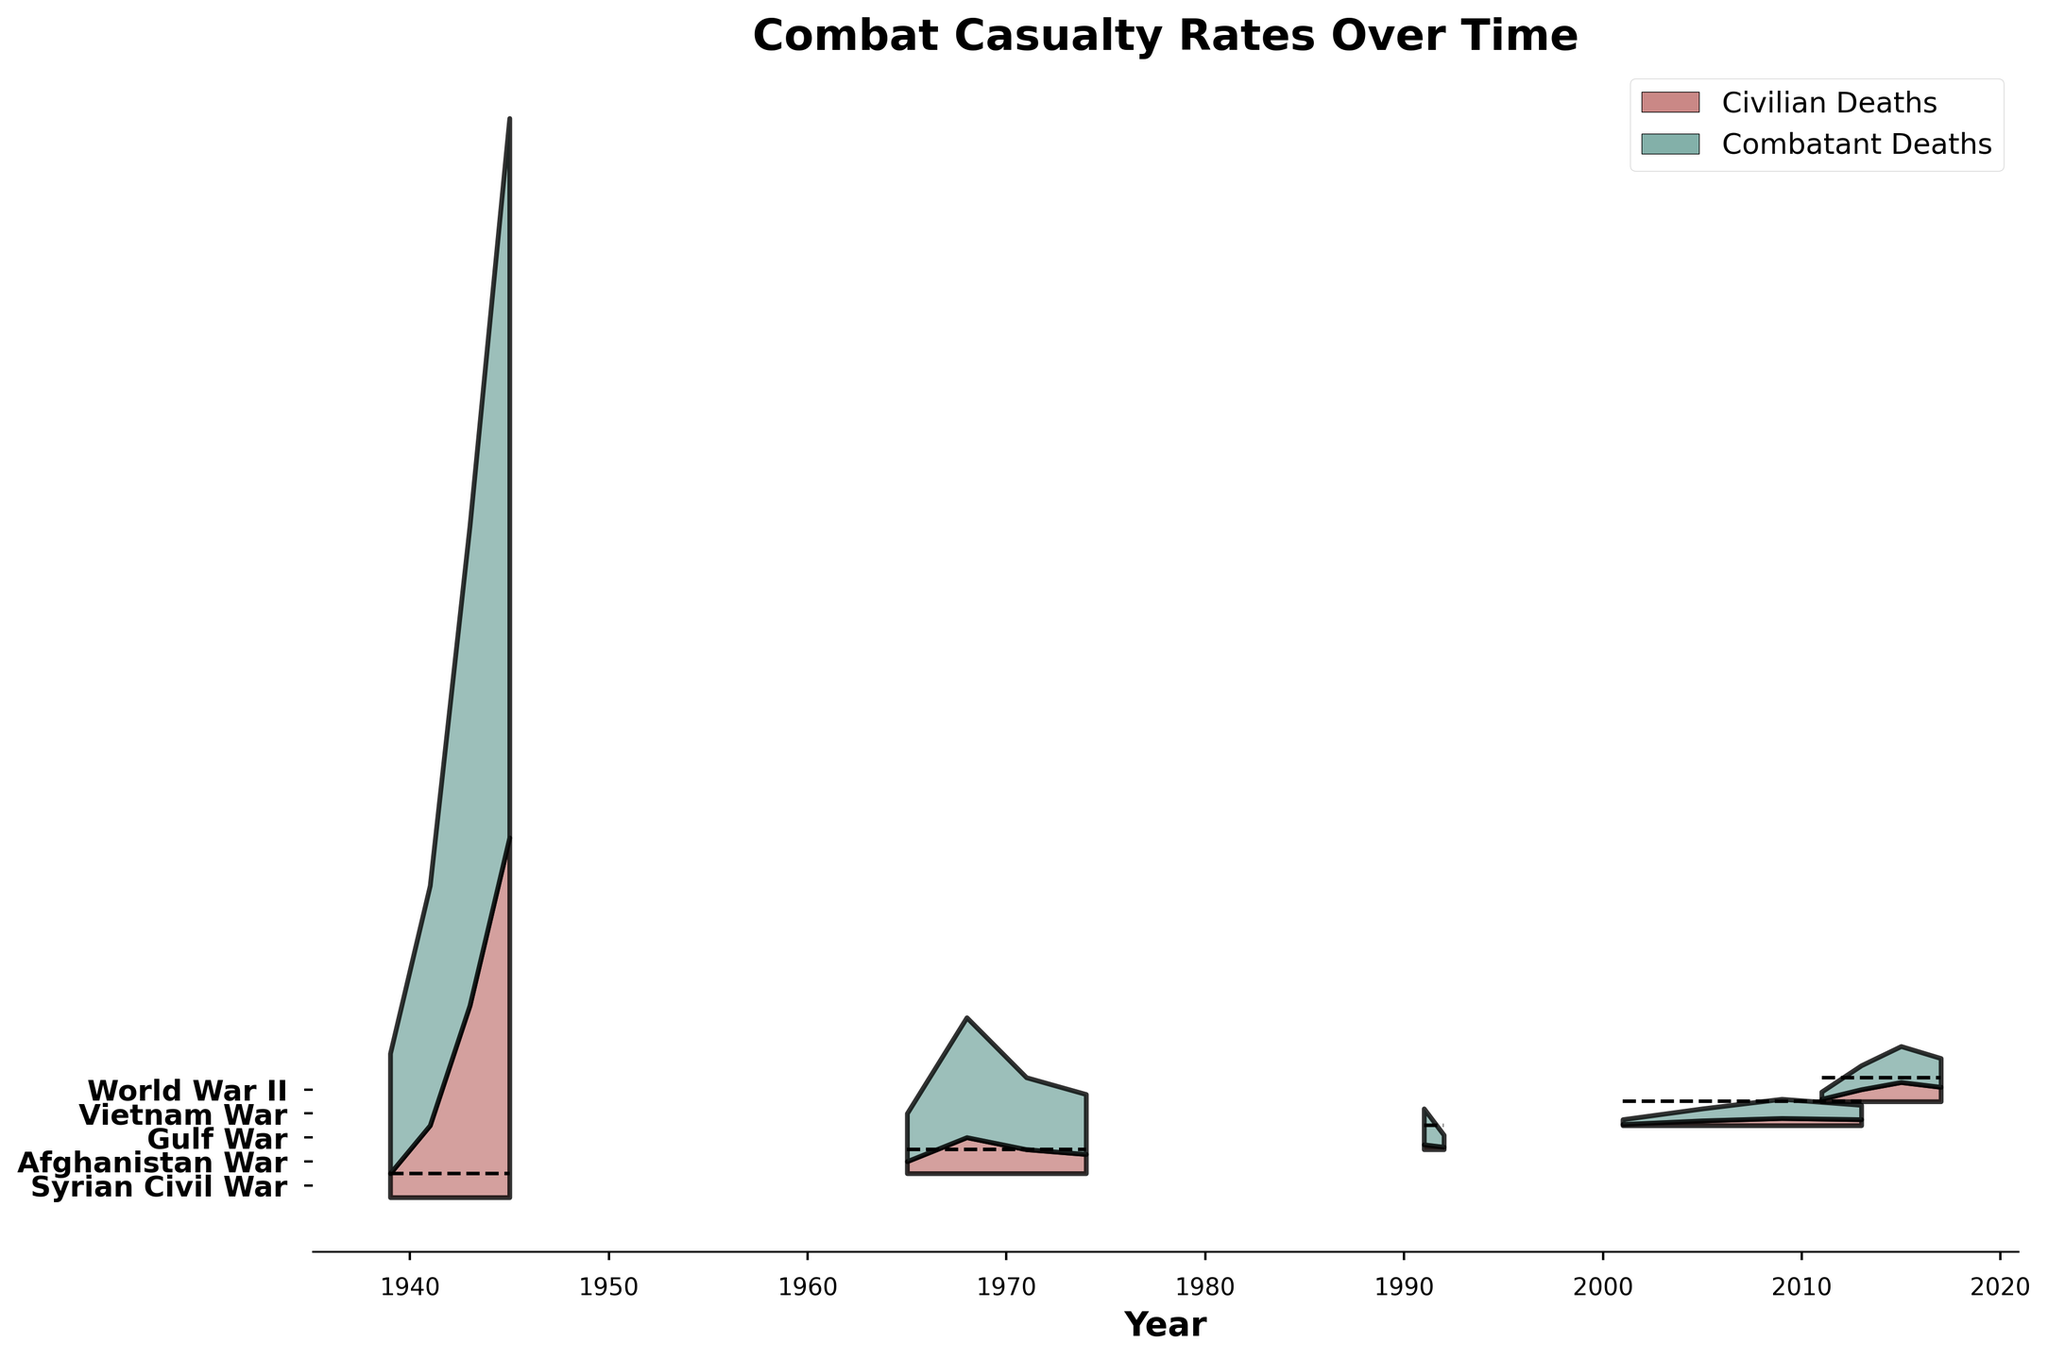What is the title of the figure? The title of a plot usually appears at the top of the figure. Here the title "Combat Casualty Rates Over Time" is written in bold font, which is clear and prominent in the figure.
Answer: Combat Casualty Rates Over Time How many unique military conflicts are represented in the figure? The labels on the y-axis represent unique military conflicts. By counting the unique labels, we determine there are five conflicts represented.
Answer: 5 Which conflict shows the highest civilian deaths at any point in time? By observing the height of the filled area representing civilian deaths across different conflicts, World War II has the highest segment (150,000 deaths in 1945) compared to others.
Answer: World War II In which year did the Vietnam War see the highest combined deaths (civilian + combatant)? In the Vietnam War conflict segment, the height of the combined filled area (both civilian and combatant deaths) is highest in 1968. Adding civilian and combatant deaths (15,000 + 50,000), 1968 shows the peak.
Answer: 1968 How do civilian deaths in the Gulf War compare between 1991 and 1992? Look at the height of the civilian deaths segment for the Gulf War in 1991 and 1992. The height is taller in 1991 (2,000 deaths) than in 1992 (1,000 deaths).
Answer: 1991 had more civilian deaths What trend do you observe in the Afghanistan War regarding combatant deaths over the years? Observing the combatant deaths segment in the Afghanistan War, deaths increased from 2001 (2,000) through 2009 (8,000) and then slightly decreased by 2013 (6,000).
Answer: Increasing then decreasing Which military conflict reported the lowest civilian deaths in the first year mentioned? Look at the first year of each conflict and check the civilian deaths segment. The lowest value (500 deaths) appears in the Afghanistan War in 2001.
Answer: Afghanistan War Are there any conflicts where the maximum civilian deaths did not surpass 10,000? Scan through each conflict and identify the maximum civilian deaths. The Gulf War and the Afghanistan War both have maximum civilian deaths below 10,000.
Answer: Gulf War, Afghanistan War During which year did World War II report the steepest increase in deaths (civilian + combatant)? Observe the combined height differences between consecutive years in World War II. From 1941 to 1943, the height increase is the steepest, going from 130,000 to 280,000 deaths.
Answer: 1941 to 1943 